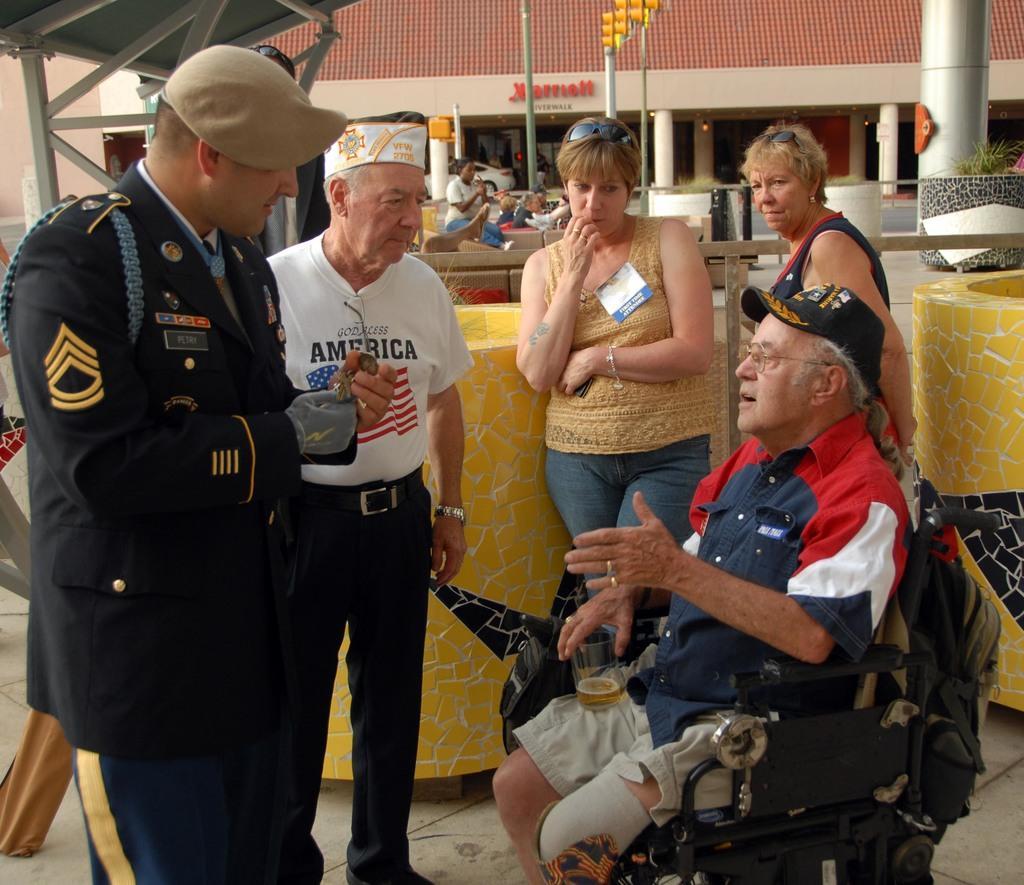How would you summarize this image in a sentence or two? In this image there are persons standing and sitting. In the center there are objects which are yellow in colour. In the background there are persons sitting and there are plants, pillars, poles and building with some text written on the wall of the building. On the left side there is a stand. 